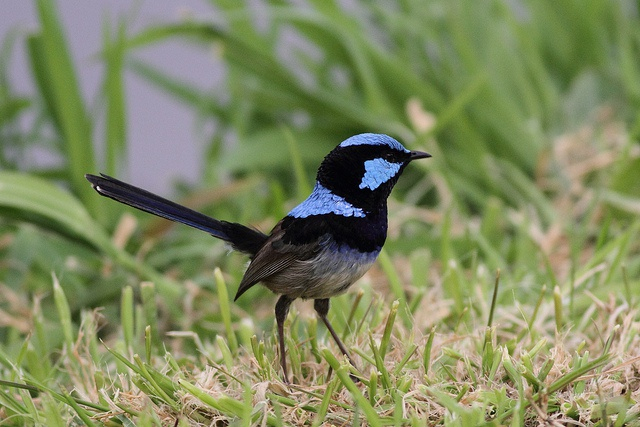Describe the objects in this image and their specific colors. I can see a bird in darkgray, black, gray, and lightblue tones in this image. 